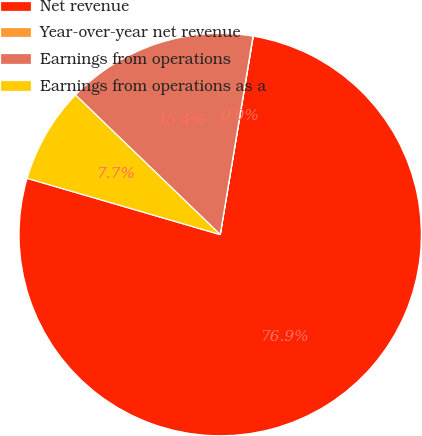<chart> <loc_0><loc_0><loc_500><loc_500><pie_chart><fcel>Net revenue<fcel>Year-over-year net revenue<fcel>Earnings from operations<fcel>Earnings from operations as a<nl><fcel>76.89%<fcel>0.02%<fcel>15.39%<fcel>7.7%<nl></chart> 